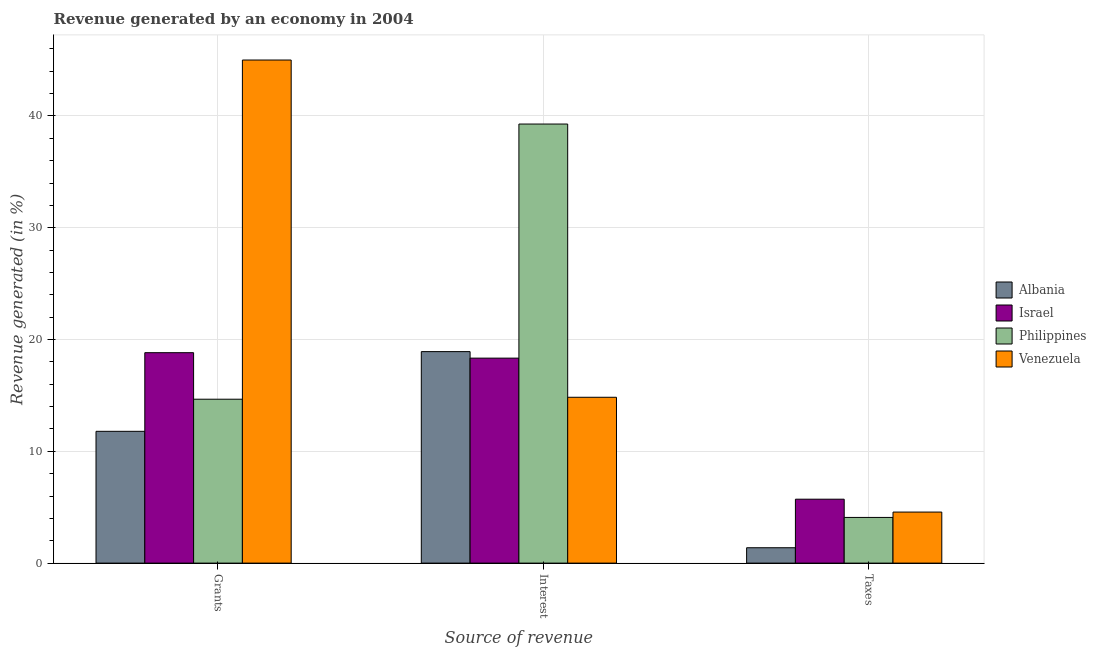How many different coloured bars are there?
Ensure brevity in your answer.  4. How many groups of bars are there?
Provide a succinct answer. 3. What is the label of the 3rd group of bars from the left?
Your response must be concise. Taxes. What is the percentage of revenue generated by interest in Albania?
Provide a succinct answer. 18.92. Across all countries, what is the maximum percentage of revenue generated by grants?
Make the answer very short. 45. Across all countries, what is the minimum percentage of revenue generated by taxes?
Your answer should be compact. 1.38. In which country was the percentage of revenue generated by interest maximum?
Your answer should be very brief. Philippines. In which country was the percentage of revenue generated by interest minimum?
Offer a terse response. Venezuela. What is the total percentage of revenue generated by taxes in the graph?
Give a very brief answer. 15.75. What is the difference between the percentage of revenue generated by grants in Philippines and that in Israel?
Your answer should be very brief. -4.16. What is the difference between the percentage of revenue generated by taxes in Philippines and the percentage of revenue generated by interest in Venezuela?
Provide a succinct answer. -10.75. What is the average percentage of revenue generated by taxes per country?
Ensure brevity in your answer.  3.94. What is the difference between the percentage of revenue generated by interest and percentage of revenue generated by taxes in Venezuela?
Your answer should be compact. 10.27. In how many countries, is the percentage of revenue generated by grants greater than 28 %?
Your answer should be very brief. 1. What is the ratio of the percentage of revenue generated by interest in Israel to that in Albania?
Offer a terse response. 0.97. Is the percentage of revenue generated by grants in Philippines less than that in Israel?
Provide a short and direct response. Yes. What is the difference between the highest and the second highest percentage of revenue generated by interest?
Make the answer very short. 20.36. What is the difference between the highest and the lowest percentage of revenue generated by grants?
Provide a succinct answer. 33.21. Is the sum of the percentage of revenue generated by interest in Philippines and Venezuela greater than the maximum percentage of revenue generated by grants across all countries?
Provide a succinct answer. Yes. How many bars are there?
Your answer should be very brief. 12. What is the difference between two consecutive major ticks on the Y-axis?
Provide a succinct answer. 10. How are the legend labels stacked?
Your response must be concise. Vertical. What is the title of the graph?
Provide a short and direct response. Revenue generated by an economy in 2004. Does "Low & middle income" appear as one of the legend labels in the graph?
Your answer should be compact. No. What is the label or title of the X-axis?
Provide a succinct answer. Source of revenue. What is the label or title of the Y-axis?
Provide a short and direct response. Revenue generated (in %). What is the Revenue generated (in %) in Albania in Grants?
Your response must be concise. 11.79. What is the Revenue generated (in %) of Israel in Grants?
Your answer should be very brief. 18.82. What is the Revenue generated (in %) of Philippines in Grants?
Your answer should be compact. 14.66. What is the Revenue generated (in %) of Venezuela in Grants?
Keep it short and to the point. 45. What is the Revenue generated (in %) of Albania in Interest?
Make the answer very short. 18.92. What is the Revenue generated (in %) of Israel in Interest?
Offer a terse response. 18.34. What is the Revenue generated (in %) of Philippines in Interest?
Provide a short and direct response. 39.28. What is the Revenue generated (in %) in Venezuela in Interest?
Your answer should be very brief. 14.83. What is the Revenue generated (in %) of Albania in Taxes?
Your response must be concise. 1.38. What is the Revenue generated (in %) in Israel in Taxes?
Provide a short and direct response. 5.72. What is the Revenue generated (in %) of Philippines in Taxes?
Your answer should be compact. 4.09. What is the Revenue generated (in %) of Venezuela in Taxes?
Offer a very short reply. 4.57. Across all Source of revenue, what is the maximum Revenue generated (in %) in Albania?
Ensure brevity in your answer.  18.92. Across all Source of revenue, what is the maximum Revenue generated (in %) in Israel?
Offer a very short reply. 18.82. Across all Source of revenue, what is the maximum Revenue generated (in %) of Philippines?
Provide a short and direct response. 39.28. Across all Source of revenue, what is the maximum Revenue generated (in %) of Venezuela?
Provide a short and direct response. 45. Across all Source of revenue, what is the minimum Revenue generated (in %) of Albania?
Make the answer very short. 1.38. Across all Source of revenue, what is the minimum Revenue generated (in %) in Israel?
Offer a very short reply. 5.72. Across all Source of revenue, what is the minimum Revenue generated (in %) of Philippines?
Provide a short and direct response. 4.09. Across all Source of revenue, what is the minimum Revenue generated (in %) of Venezuela?
Make the answer very short. 4.57. What is the total Revenue generated (in %) in Albania in the graph?
Your response must be concise. 32.08. What is the total Revenue generated (in %) of Israel in the graph?
Your response must be concise. 42.88. What is the total Revenue generated (in %) of Philippines in the graph?
Offer a terse response. 58.03. What is the total Revenue generated (in %) of Venezuela in the graph?
Give a very brief answer. 64.4. What is the difference between the Revenue generated (in %) in Albania in Grants and that in Interest?
Give a very brief answer. -7.13. What is the difference between the Revenue generated (in %) in Israel in Grants and that in Interest?
Give a very brief answer. 0.49. What is the difference between the Revenue generated (in %) in Philippines in Grants and that in Interest?
Make the answer very short. -24.61. What is the difference between the Revenue generated (in %) of Venezuela in Grants and that in Interest?
Provide a short and direct response. 30.17. What is the difference between the Revenue generated (in %) of Albania in Grants and that in Taxes?
Ensure brevity in your answer.  10.41. What is the difference between the Revenue generated (in %) in Israel in Grants and that in Taxes?
Your answer should be very brief. 13.11. What is the difference between the Revenue generated (in %) in Philippines in Grants and that in Taxes?
Provide a short and direct response. 10.58. What is the difference between the Revenue generated (in %) of Venezuela in Grants and that in Taxes?
Keep it short and to the point. 40.44. What is the difference between the Revenue generated (in %) in Albania in Interest and that in Taxes?
Your answer should be very brief. 17.54. What is the difference between the Revenue generated (in %) in Israel in Interest and that in Taxes?
Provide a short and direct response. 12.62. What is the difference between the Revenue generated (in %) of Philippines in Interest and that in Taxes?
Provide a short and direct response. 35.19. What is the difference between the Revenue generated (in %) of Venezuela in Interest and that in Taxes?
Offer a terse response. 10.27. What is the difference between the Revenue generated (in %) in Albania in Grants and the Revenue generated (in %) in Israel in Interest?
Offer a very short reply. -6.55. What is the difference between the Revenue generated (in %) in Albania in Grants and the Revenue generated (in %) in Philippines in Interest?
Your response must be concise. -27.49. What is the difference between the Revenue generated (in %) in Albania in Grants and the Revenue generated (in %) in Venezuela in Interest?
Keep it short and to the point. -3.05. What is the difference between the Revenue generated (in %) of Israel in Grants and the Revenue generated (in %) of Philippines in Interest?
Offer a terse response. -20.45. What is the difference between the Revenue generated (in %) in Israel in Grants and the Revenue generated (in %) in Venezuela in Interest?
Provide a succinct answer. 3.99. What is the difference between the Revenue generated (in %) of Philippines in Grants and the Revenue generated (in %) of Venezuela in Interest?
Give a very brief answer. -0.17. What is the difference between the Revenue generated (in %) in Albania in Grants and the Revenue generated (in %) in Israel in Taxes?
Give a very brief answer. 6.07. What is the difference between the Revenue generated (in %) in Albania in Grants and the Revenue generated (in %) in Philippines in Taxes?
Provide a short and direct response. 7.7. What is the difference between the Revenue generated (in %) in Albania in Grants and the Revenue generated (in %) in Venezuela in Taxes?
Offer a very short reply. 7.22. What is the difference between the Revenue generated (in %) in Israel in Grants and the Revenue generated (in %) in Philippines in Taxes?
Your response must be concise. 14.74. What is the difference between the Revenue generated (in %) in Israel in Grants and the Revenue generated (in %) in Venezuela in Taxes?
Provide a short and direct response. 14.26. What is the difference between the Revenue generated (in %) of Philippines in Grants and the Revenue generated (in %) of Venezuela in Taxes?
Ensure brevity in your answer.  10.1. What is the difference between the Revenue generated (in %) of Albania in Interest and the Revenue generated (in %) of Israel in Taxes?
Make the answer very short. 13.2. What is the difference between the Revenue generated (in %) of Albania in Interest and the Revenue generated (in %) of Philippines in Taxes?
Your response must be concise. 14.83. What is the difference between the Revenue generated (in %) of Albania in Interest and the Revenue generated (in %) of Venezuela in Taxes?
Offer a terse response. 14.35. What is the difference between the Revenue generated (in %) of Israel in Interest and the Revenue generated (in %) of Philippines in Taxes?
Keep it short and to the point. 14.25. What is the difference between the Revenue generated (in %) of Israel in Interest and the Revenue generated (in %) of Venezuela in Taxes?
Your answer should be very brief. 13.77. What is the difference between the Revenue generated (in %) of Philippines in Interest and the Revenue generated (in %) of Venezuela in Taxes?
Your response must be concise. 34.71. What is the average Revenue generated (in %) in Albania per Source of revenue?
Your answer should be very brief. 10.69. What is the average Revenue generated (in %) in Israel per Source of revenue?
Offer a very short reply. 14.29. What is the average Revenue generated (in %) of Philippines per Source of revenue?
Your response must be concise. 19.34. What is the average Revenue generated (in %) of Venezuela per Source of revenue?
Offer a terse response. 21.47. What is the difference between the Revenue generated (in %) of Albania and Revenue generated (in %) of Israel in Grants?
Make the answer very short. -7.04. What is the difference between the Revenue generated (in %) in Albania and Revenue generated (in %) in Philippines in Grants?
Give a very brief answer. -2.87. What is the difference between the Revenue generated (in %) of Albania and Revenue generated (in %) of Venezuela in Grants?
Your response must be concise. -33.21. What is the difference between the Revenue generated (in %) in Israel and Revenue generated (in %) in Philippines in Grants?
Your answer should be compact. 4.16. What is the difference between the Revenue generated (in %) in Israel and Revenue generated (in %) in Venezuela in Grants?
Ensure brevity in your answer.  -26.18. What is the difference between the Revenue generated (in %) in Philippines and Revenue generated (in %) in Venezuela in Grants?
Offer a terse response. -30.34. What is the difference between the Revenue generated (in %) in Albania and Revenue generated (in %) in Israel in Interest?
Your response must be concise. 0.58. What is the difference between the Revenue generated (in %) in Albania and Revenue generated (in %) in Philippines in Interest?
Provide a succinct answer. -20.36. What is the difference between the Revenue generated (in %) of Albania and Revenue generated (in %) of Venezuela in Interest?
Your answer should be compact. 4.08. What is the difference between the Revenue generated (in %) in Israel and Revenue generated (in %) in Philippines in Interest?
Provide a short and direct response. -20.94. What is the difference between the Revenue generated (in %) of Israel and Revenue generated (in %) of Venezuela in Interest?
Your answer should be very brief. 3.5. What is the difference between the Revenue generated (in %) of Philippines and Revenue generated (in %) of Venezuela in Interest?
Your answer should be very brief. 24.44. What is the difference between the Revenue generated (in %) in Albania and Revenue generated (in %) in Israel in Taxes?
Make the answer very short. -4.34. What is the difference between the Revenue generated (in %) in Albania and Revenue generated (in %) in Philippines in Taxes?
Provide a short and direct response. -2.71. What is the difference between the Revenue generated (in %) of Albania and Revenue generated (in %) of Venezuela in Taxes?
Offer a very short reply. -3.19. What is the difference between the Revenue generated (in %) in Israel and Revenue generated (in %) in Philippines in Taxes?
Make the answer very short. 1.63. What is the difference between the Revenue generated (in %) in Israel and Revenue generated (in %) in Venezuela in Taxes?
Provide a succinct answer. 1.15. What is the difference between the Revenue generated (in %) in Philippines and Revenue generated (in %) in Venezuela in Taxes?
Provide a succinct answer. -0.48. What is the ratio of the Revenue generated (in %) of Albania in Grants to that in Interest?
Your answer should be very brief. 0.62. What is the ratio of the Revenue generated (in %) in Israel in Grants to that in Interest?
Provide a short and direct response. 1.03. What is the ratio of the Revenue generated (in %) of Philippines in Grants to that in Interest?
Your response must be concise. 0.37. What is the ratio of the Revenue generated (in %) of Venezuela in Grants to that in Interest?
Your answer should be very brief. 3.03. What is the ratio of the Revenue generated (in %) in Albania in Grants to that in Taxes?
Your answer should be very brief. 8.57. What is the ratio of the Revenue generated (in %) of Israel in Grants to that in Taxes?
Provide a short and direct response. 3.29. What is the ratio of the Revenue generated (in %) of Philippines in Grants to that in Taxes?
Provide a short and direct response. 3.59. What is the ratio of the Revenue generated (in %) in Venezuela in Grants to that in Taxes?
Your response must be concise. 9.85. What is the ratio of the Revenue generated (in %) in Albania in Interest to that in Taxes?
Provide a short and direct response. 13.76. What is the ratio of the Revenue generated (in %) of Israel in Interest to that in Taxes?
Provide a succinct answer. 3.21. What is the ratio of the Revenue generated (in %) in Philippines in Interest to that in Taxes?
Your answer should be very brief. 9.61. What is the ratio of the Revenue generated (in %) of Venezuela in Interest to that in Taxes?
Provide a short and direct response. 3.25. What is the difference between the highest and the second highest Revenue generated (in %) of Albania?
Provide a succinct answer. 7.13. What is the difference between the highest and the second highest Revenue generated (in %) in Israel?
Your answer should be compact. 0.49. What is the difference between the highest and the second highest Revenue generated (in %) in Philippines?
Offer a terse response. 24.61. What is the difference between the highest and the second highest Revenue generated (in %) of Venezuela?
Your answer should be compact. 30.17. What is the difference between the highest and the lowest Revenue generated (in %) in Albania?
Provide a short and direct response. 17.54. What is the difference between the highest and the lowest Revenue generated (in %) of Israel?
Your answer should be compact. 13.11. What is the difference between the highest and the lowest Revenue generated (in %) of Philippines?
Make the answer very short. 35.19. What is the difference between the highest and the lowest Revenue generated (in %) in Venezuela?
Give a very brief answer. 40.44. 